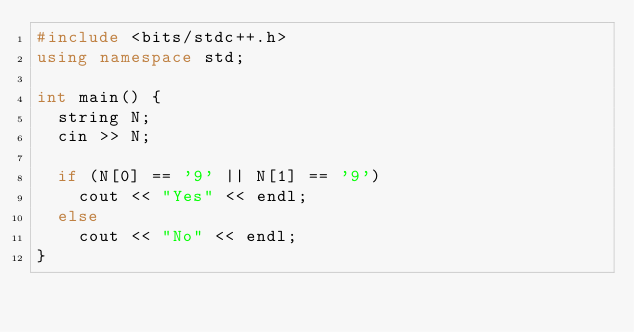Convert code to text. <code><loc_0><loc_0><loc_500><loc_500><_C++_>#include <bits/stdc++.h>
using namespace std;

int main() {
  string N;
  cin >> N;
  
  if (N[0] == '9' || N[1] == '9')
    cout << "Yes" << endl;
  else
    cout << "No" << endl;
}</code> 